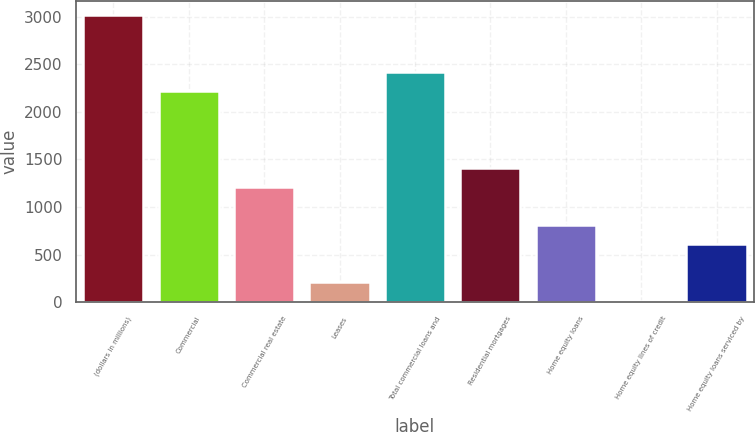Convert chart to OTSL. <chart><loc_0><loc_0><loc_500><loc_500><bar_chart><fcel>(dollars in millions)<fcel>Commercial<fcel>Commercial real estate<fcel>Leases<fcel>Total commercial loans and<fcel>Residential mortgages<fcel>Home equity loans<fcel>Home equity lines of credit<fcel>Home equity loans serviced by<nl><fcel>3017<fcel>2215.4<fcel>1213.4<fcel>211.4<fcel>2415.8<fcel>1413.8<fcel>812.6<fcel>11<fcel>612.2<nl></chart> 